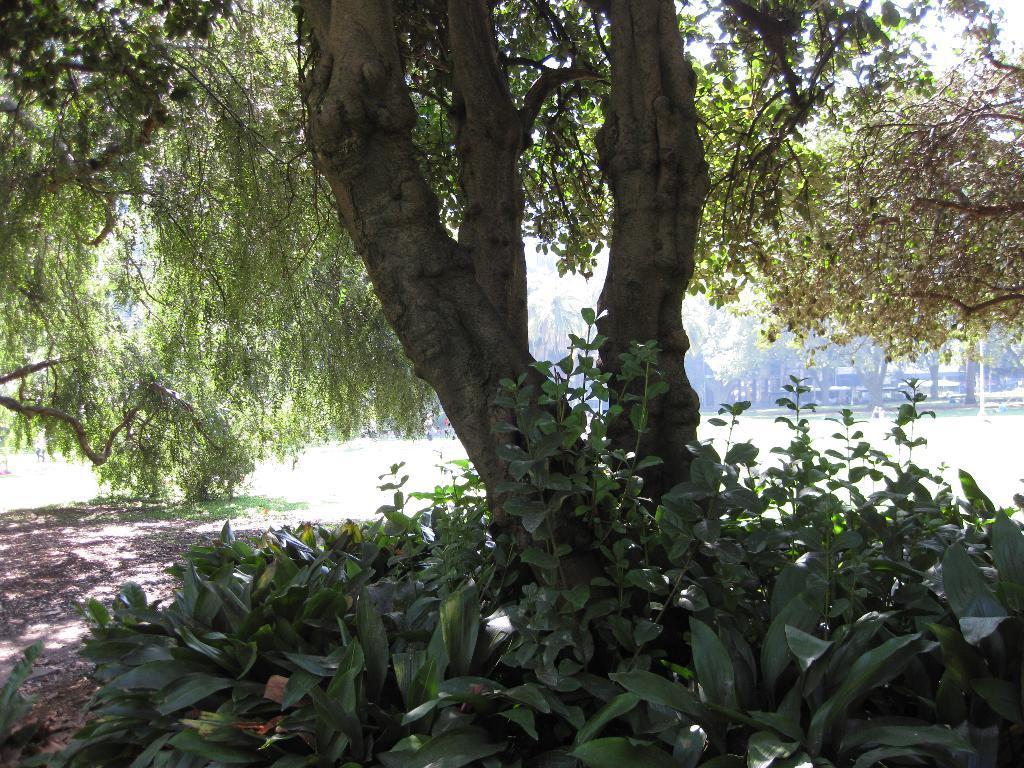Can you describe this image briefly? At the bottom of the image there are small plants with leaves. In between them there is a tree. In the background there are trees. 